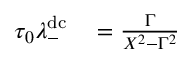Convert formula to latex. <formula><loc_0><loc_0><loc_500><loc_500>\begin{array} { r l } { \tau _ { 0 } \lambda _ { - } ^ { d c } } & = \frac { \Gamma } { X ^ { 2 } - \Gamma ^ { 2 } } } \end{array}</formula> 